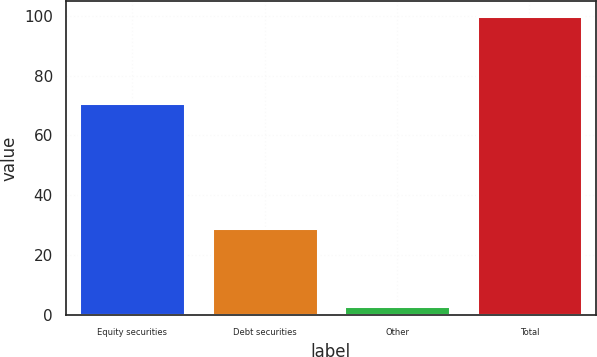<chart> <loc_0><loc_0><loc_500><loc_500><bar_chart><fcel>Equity securities<fcel>Debt securities<fcel>Other<fcel>Total<nl><fcel>71<fcel>29<fcel>2.94<fcel>100<nl></chart> 